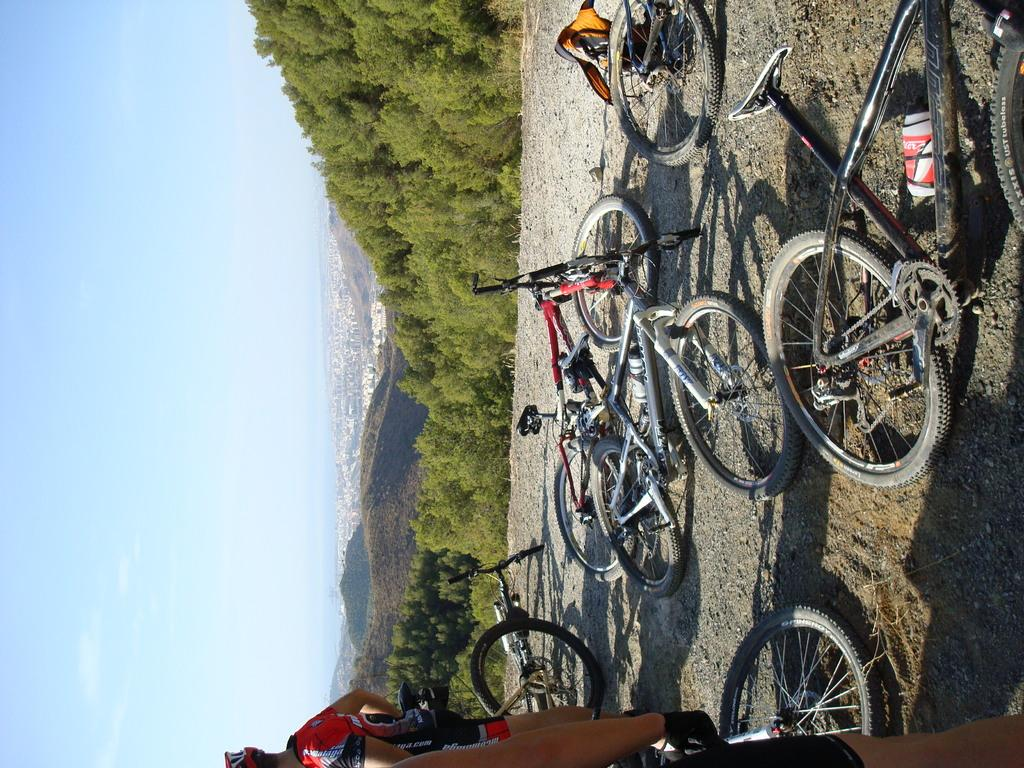What is the main subject in the center of the image? There are bicycles in the center of the image. What can be seen at the bottom of the image? There are people at the bottom of the image. What type of landscape is visible in the background of the image? There are hills and trees in the background of the image. What part of the natural environment is visible in the background of the image? The sky is visible in the background of the image. How many babies are present in the image? There are no babies present in the image. What type of country is depicted in the image? The image does not depict a specific country; it shows a landscape with bicycles, people, hills, trees, and sky. 